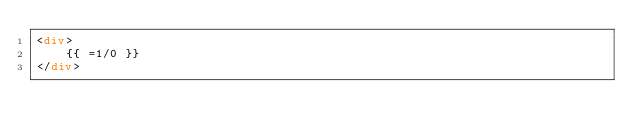<code> <loc_0><loc_0><loc_500><loc_500><_HTML_><div>
    {{ =1/0 }}
</div></code> 